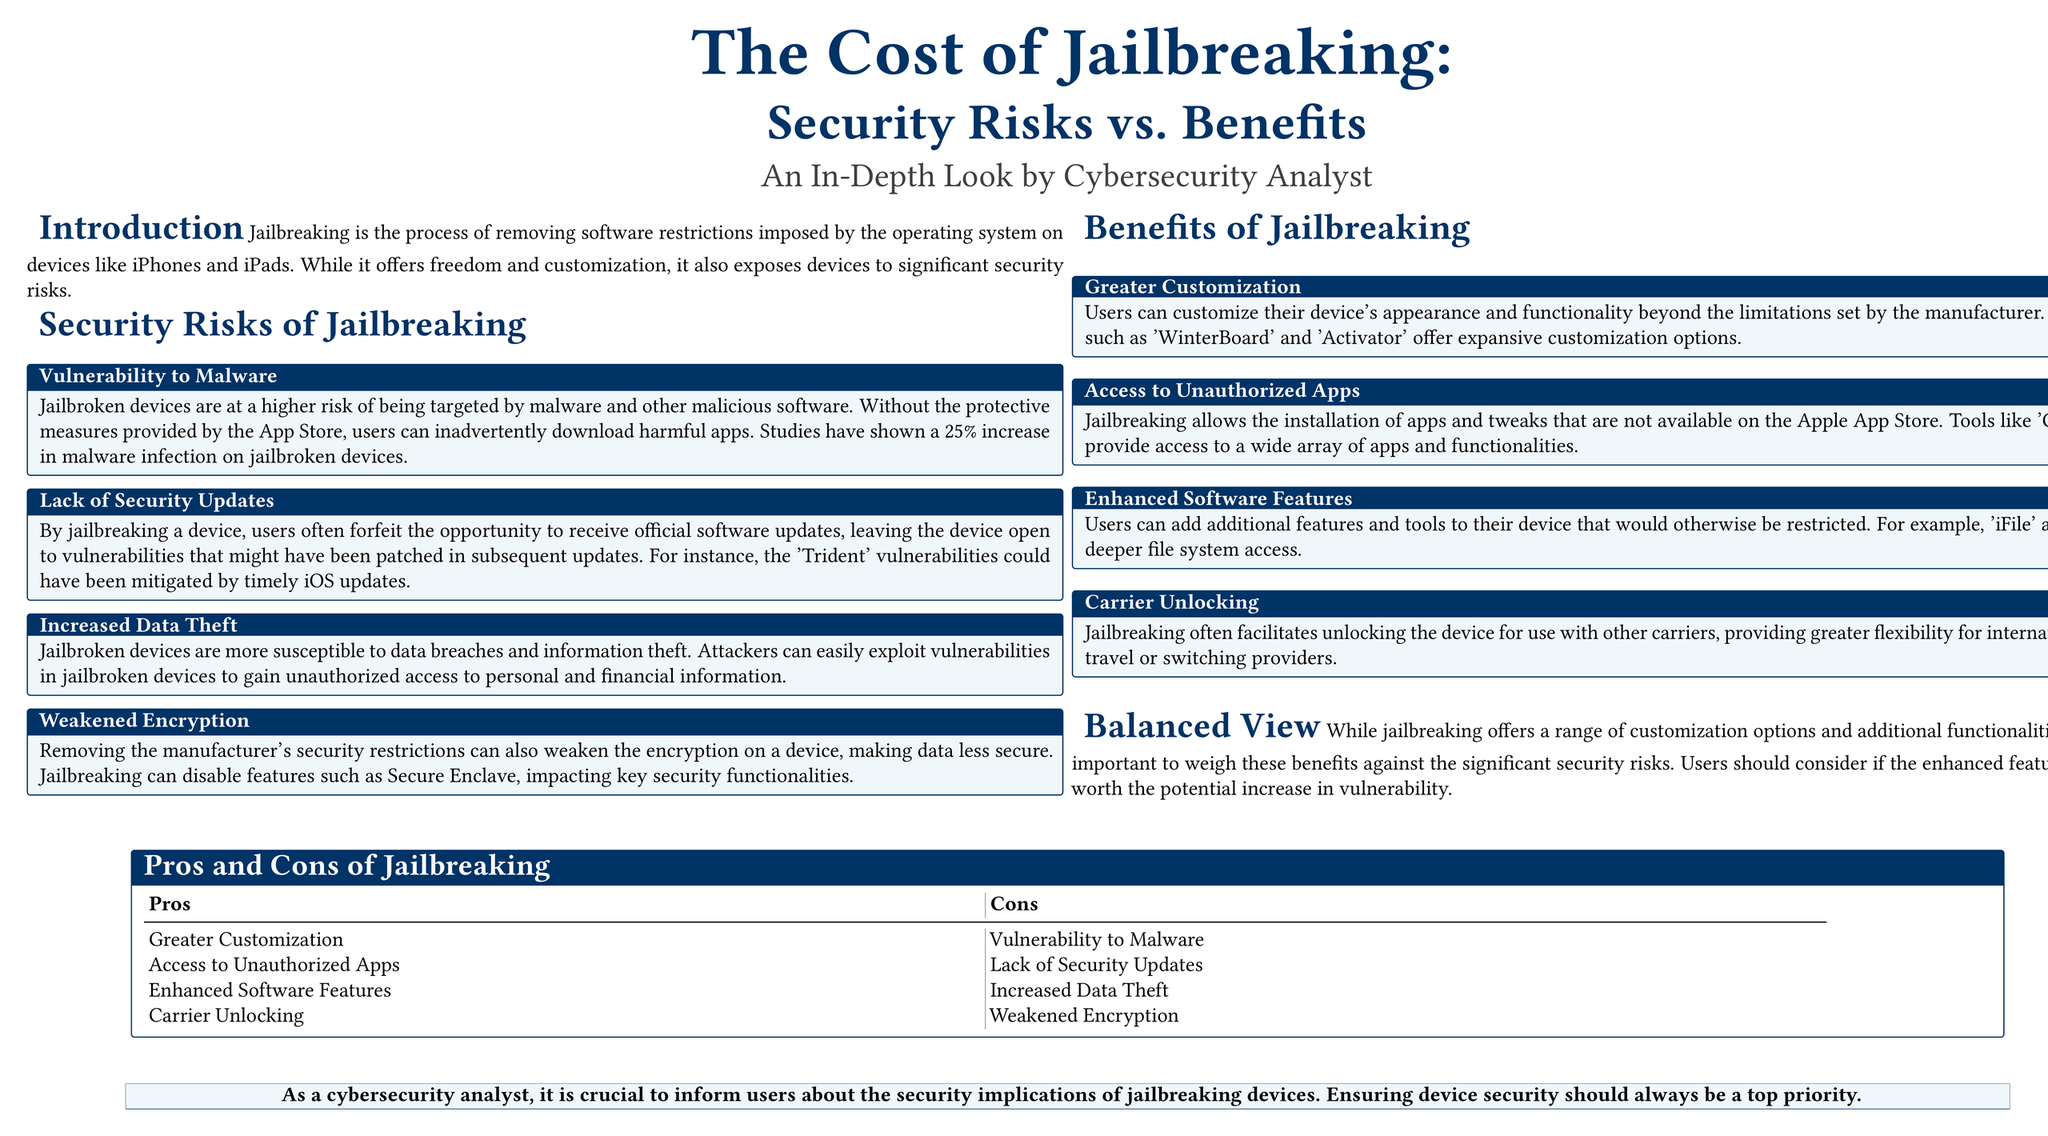What is the main topic of the poster? The main topic of the poster is about jailbreaking and its associated security risks versus benefits.
Answer: The Cost of Jailbreaking: Security Risks vs. Benefits What is one security risk highlighted in the document? The document lists several security risks associated with jailbreaking, such as vulnerability to malware.
Answer: Vulnerability to Malware What percentage increase in malware infection is shown for jailbroken devices? The document states that there is a 25% increase in malware infections on jailbroken devices.
Answer: 25% What is one benefit of jailbreaking mentioned? The poster includes several benefits of jailbreaking, such as greater customization options.
Answer: Greater Customization What does jailbreaking allow for regarding app availability? The document explains that jailbreaking allows the installation of apps that are not available on the Apple App Store.
Answer: Access to Unauthorized Apps How does jailbreaking affect security updates? The document explains that by jailbreaking, users often forfeit the opportunity to receive official software updates.
Answer: Lack of Security Updates In the pros and cons table, which category is given alongside "Carrier Unlocking"? The table lists the pros and cons of jailbreaking, pairing "Carrier Unlocking" with "Weakened Encryption" under cons.
Answer: Weakened Encryption What role does the poster attribute to the cybersecurity analyst? The poster emphasizes the primary responsibility of cybersecurity analysts to inform users about security implications.
Answer: Inform users about security implications 